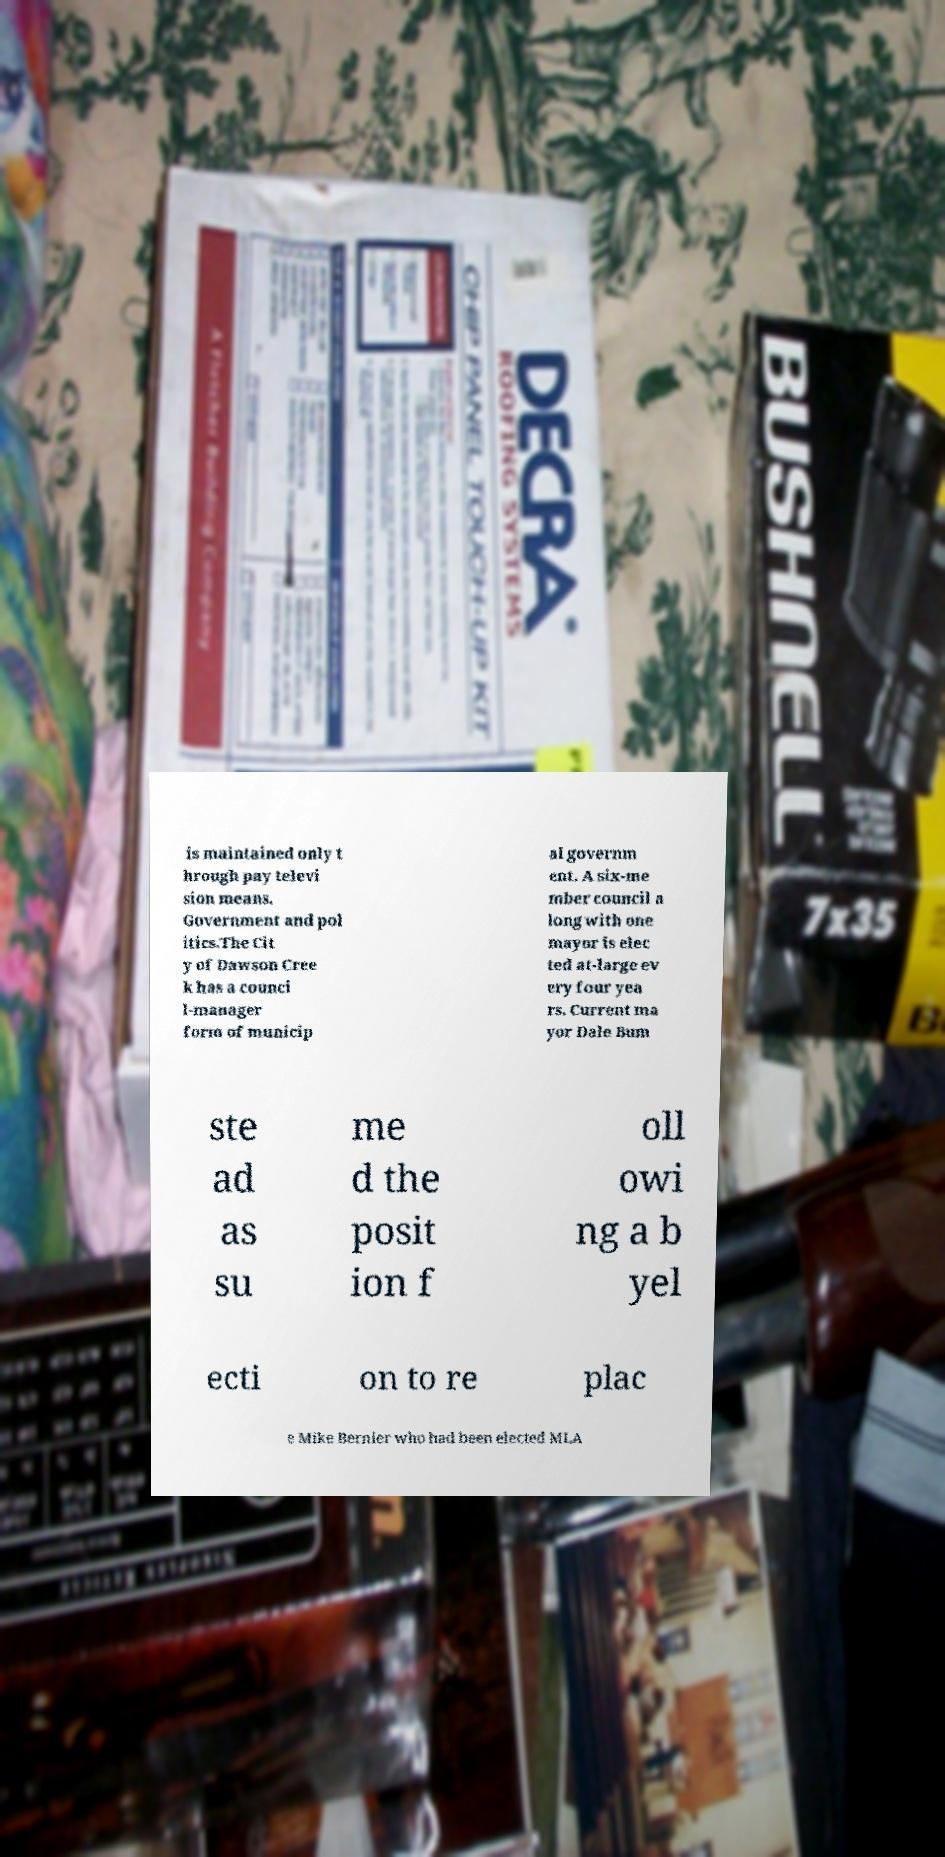Can you accurately transcribe the text from the provided image for me? is maintained only t hrough pay televi sion means. Government and pol itics.The Cit y of Dawson Cree k has a counci l-manager form of municip al governm ent. A six-me mber council a long with one mayor is elec ted at-large ev ery four yea rs. Current ma yor Dale Bum ste ad as su me d the posit ion f oll owi ng a b yel ecti on to re plac e Mike Bernier who had been elected MLA 